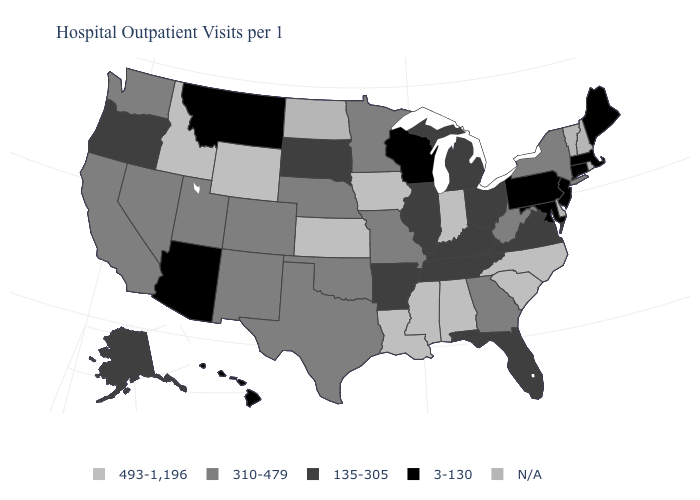What is the value of Wyoming?
Answer briefly. 493-1,196. How many symbols are there in the legend?
Write a very short answer. 5. What is the value of Wyoming?
Answer briefly. 493-1,196. Among the states that border Wisconsin , which have the highest value?
Quick response, please. Iowa. Name the states that have a value in the range 3-130?
Concise answer only. Arizona, Connecticut, Hawaii, Maine, Maryland, Massachusetts, Montana, New Jersey, Pennsylvania, Wisconsin. Among the states that border North Carolina , does Virginia have the lowest value?
Answer briefly. Yes. Name the states that have a value in the range 310-479?
Give a very brief answer. California, Colorado, Georgia, Minnesota, Missouri, Nebraska, Nevada, New Mexico, New York, Oklahoma, Texas, Utah, Washington, West Virginia. Which states have the lowest value in the South?
Short answer required. Maryland. What is the highest value in states that border California?
Short answer required. 310-479. Does Maryland have the lowest value in the USA?
Short answer required. Yes. 